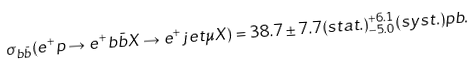Convert formula to latex. <formula><loc_0><loc_0><loc_500><loc_500>\sigma _ { b \bar { b } } ( e ^ { + } p \rightarrow e ^ { + } b \bar { b } X \rightarrow e ^ { + } j e t \mu X ) = 3 8 . 7 \pm 7 . 7 ( s t a t . ) ^ { + 6 . 1 } _ { - 5 . 0 } ( s y s t . ) p b .</formula> 